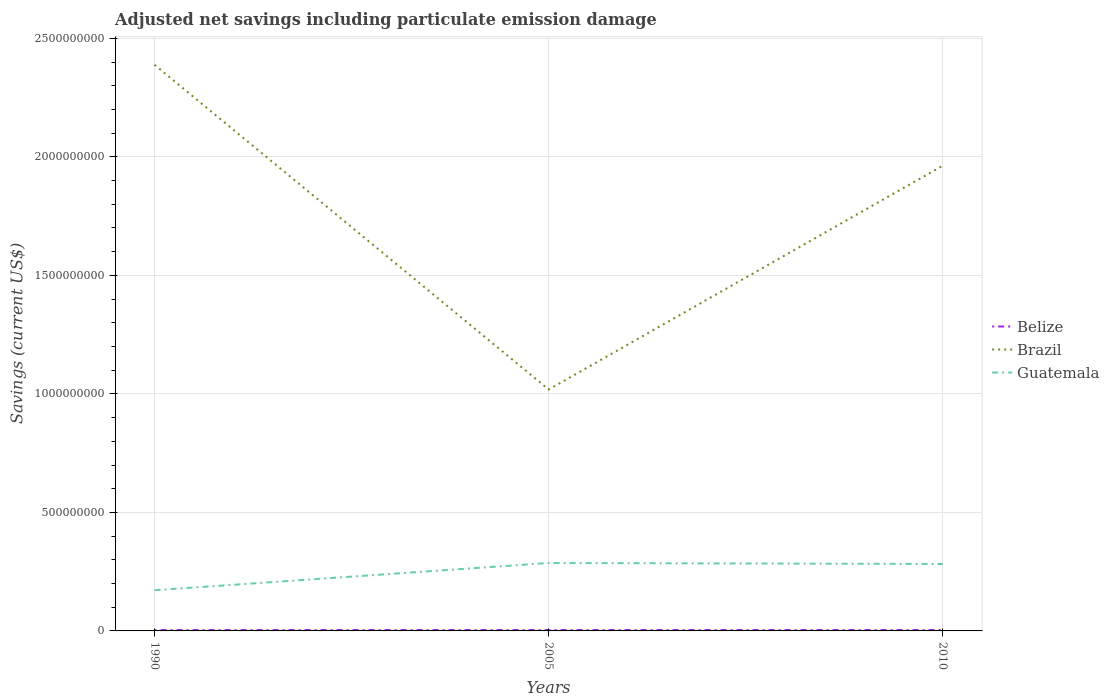Is the number of lines equal to the number of legend labels?
Your response must be concise. Yes. Across all years, what is the maximum net savings in Brazil?
Make the answer very short. 1.02e+09. In which year was the net savings in Guatemala maximum?
Provide a short and direct response. 1990. What is the total net savings in Brazil in the graph?
Give a very brief answer. 1.37e+09. What is the difference between the highest and the second highest net savings in Brazil?
Offer a terse response. 1.37e+09. What is the difference between the highest and the lowest net savings in Belize?
Your answer should be very brief. 2. Are the values on the major ticks of Y-axis written in scientific E-notation?
Your answer should be very brief. No. Does the graph contain any zero values?
Ensure brevity in your answer.  No. Where does the legend appear in the graph?
Make the answer very short. Center right. How are the legend labels stacked?
Provide a succinct answer. Vertical. What is the title of the graph?
Provide a succinct answer. Adjusted net savings including particulate emission damage. What is the label or title of the X-axis?
Keep it short and to the point. Years. What is the label or title of the Y-axis?
Your answer should be compact. Savings (current US$). What is the Savings (current US$) in Belize in 1990?
Make the answer very short. 3.60e+06. What is the Savings (current US$) in Brazil in 1990?
Your response must be concise. 2.39e+09. What is the Savings (current US$) of Guatemala in 1990?
Your answer should be compact. 1.72e+08. What is the Savings (current US$) of Belize in 2005?
Ensure brevity in your answer.  3.78e+06. What is the Savings (current US$) in Brazil in 2005?
Provide a short and direct response. 1.02e+09. What is the Savings (current US$) of Guatemala in 2005?
Your answer should be very brief. 2.87e+08. What is the Savings (current US$) of Belize in 2010?
Your answer should be compact. 3.82e+06. What is the Savings (current US$) in Brazil in 2010?
Your response must be concise. 1.96e+09. What is the Savings (current US$) in Guatemala in 2010?
Ensure brevity in your answer.  2.83e+08. Across all years, what is the maximum Savings (current US$) in Belize?
Offer a terse response. 3.82e+06. Across all years, what is the maximum Savings (current US$) in Brazil?
Offer a very short reply. 2.39e+09. Across all years, what is the maximum Savings (current US$) of Guatemala?
Offer a terse response. 2.87e+08. Across all years, what is the minimum Savings (current US$) of Belize?
Your answer should be very brief. 3.60e+06. Across all years, what is the minimum Savings (current US$) in Brazil?
Ensure brevity in your answer.  1.02e+09. Across all years, what is the minimum Savings (current US$) in Guatemala?
Make the answer very short. 1.72e+08. What is the total Savings (current US$) of Belize in the graph?
Your response must be concise. 1.12e+07. What is the total Savings (current US$) of Brazil in the graph?
Your response must be concise. 5.37e+09. What is the total Savings (current US$) of Guatemala in the graph?
Offer a terse response. 7.41e+08. What is the difference between the Savings (current US$) in Belize in 1990 and that in 2005?
Keep it short and to the point. -1.86e+05. What is the difference between the Savings (current US$) of Brazil in 1990 and that in 2005?
Give a very brief answer. 1.37e+09. What is the difference between the Savings (current US$) of Guatemala in 1990 and that in 2005?
Give a very brief answer. -1.15e+08. What is the difference between the Savings (current US$) in Belize in 1990 and that in 2010?
Your answer should be compact. -2.20e+05. What is the difference between the Savings (current US$) of Brazil in 1990 and that in 2010?
Make the answer very short. 4.26e+08. What is the difference between the Savings (current US$) in Guatemala in 1990 and that in 2010?
Make the answer very short. -1.11e+08. What is the difference between the Savings (current US$) of Belize in 2005 and that in 2010?
Ensure brevity in your answer.  -3.43e+04. What is the difference between the Savings (current US$) of Brazil in 2005 and that in 2010?
Provide a succinct answer. -9.44e+08. What is the difference between the Savings (current US$) of Guatemala in 2005 and that in 2010?
Your answer should be compact. 4.13e+06. What is the difference between the Savings (current US$) of Belize in 1990 and the Savings (current US$) of Brazil in 2005?
Your answer should be compact. -1.01e+09. What is the difference between the Savings (current US$) in Belize in 1990 and the Savings (current US$) in Guatemala in 2005?
Your answer should be very brief. -2.83e+08. What is the difference between the Savings (current US$) in Brazil in 1990 and the Savings (current US$) in Guatemala in 2005?
Your answer should be compact. 2.10e+09. What is the difference between the Savings (current US$) in Belize in 1990 and the Savings (current US$) in Brazil in 2010?
Provide a short and direct response. -1.96e+09. What is the difference between the Savings (current US$) of Belize in 1990 and the Savings (current US$) of Guatemala in 2010?
Provide a succinct answer. -2.79e+08. What is the difference between the Savings (current US$) in Brazil in 1990 and the Savings (current US$) in Guatemala in 2010?
Provide a short and direct response. 2.11e+09. What is the difference between the Savings (current US$) of Belize in 2005 and the Savings (current US$) of Brazil in 2010?
Offer a very short reply. -1.96e+09. What is the difference between the Savings (current US$) of Belize in 2005 and the Savings (current US$) of Guatemala in 2010?
Make the answer very short. -2.79e+08. What is the difference between the Savings (current US$) of Brazil in 2005 and the Savings (current US$) of Guatemala in 2010?
Make the answer very short. 7.36e+08. What is the average Savings (current US$) in Belize per year?
Your response must be concise. 3.73e+06. What is the average Savings (current US$) of Brazil per year?
Offer a very short reply. 1.79e+09. What is the average Savings (current US$) of Guatemala per year?
Your answer should be very brief. 2.47e+08. In the year 1990, what is the difference between the Savings (current US$) in Belize and Savings (current US$) in Brazil?
Make the answer very short. -2.38e+09. In the year 1990, what is the difference between the Savings (current US$) of Belize and Savings (current US$) of Guatemala?
Offer a very short reply. -1.68e+08. In the year 1990, what is the difference between the Savings (current US$) of Brazil and Savings (current US$) of Guatemala?
Give a very brief answer. 2.22e+09. In the year 2005, what is the difference between the Savings (current US$) of Belize and Savings (current US$) of Brazil?
Make the answer very short. -1.01e+09. In the year 2005, what is the difference between the Savings (current US$) in Belize and Savings (current US$) in Guatemala?
Your response must be concise. -2.83e+08. In the year 2005, what is the difference between the Savings (current US$) in Brazil and Savings (current US$) in Guatemala?
Provide a short and direct response. 7.32e+08. In the year 2010, what is the difference between the Savings (current US$) of Belize and Savings (current US$) of Brazil?
Your response must be concise. -1.96e+09. In the year 2010, what is the difference between the Savings (current US$) in Belize and Savings (current US$) in Guatemala?
Ensure brevity in your answer.  -2.79e+08. In the year 2010, what is the difference between the Savings (current US$) in Brazil and Savings (current US$) in Guatemala?
Give a very brief answer. 1.68e+09. What is the ratio of the Savings (current US$) in Belize in 1990 to that in 2005?
Offer a terse response. 0.95. What is the ratio of the Savings (current US$) in Brazil in 1990 to that in 2005?
Give a very brief answer. 2.34. What is the ratio of the Savings (current US$) in Guatemala in 1990 to that in 2005?
Offer a very short reply. 0.6. What is the ratio of the Savings (current US$) in Belize in 1990 to that in 2010?
Offer a very short reply. 0.94. What is the ratio of the Savings (current US$) in Brazil in 1990 to that in 2010?
Offer a terse response. 1.22. What is the ratio of the Savings (current US$) of Guatemala in 1990 to that in 2010?
Make the answer very short. 0.61. What is the ratio of the Savings (current US$) of Brazil in 2005 to that in 2010?
Provide a succinct answer. 0.52. What is the ratio of the Savings (current US$) of Guatemala in 2005 to that in 2010?
Your answer should be compact. 1.01. What is the difference between the highest and the second highest Savings (current US$) in Belize?
Make the answer very short. 3.43e+04. What is the difference between the highest and the second highest Savings (current US$) in Brazil?
Provide a short and direct response. 4.26e+08. What is the difference between the highest and the second highest Savings (current US$) of Guatemala?
Provide a short and direct response. 4.13e+06. What is the difference between the highest and the lowest Savings (current US$) of Belize?
Give a very brief answer. 2.20e+05. What is the difference between the highest and the lowest Savings (current US$) of Brazil?
Offer a terse response. 1.37e+09. What is the difference between the highest and the lowest Savings (current US$) in Guatemala?
Your answer should be very brief. 1.15e+08. 